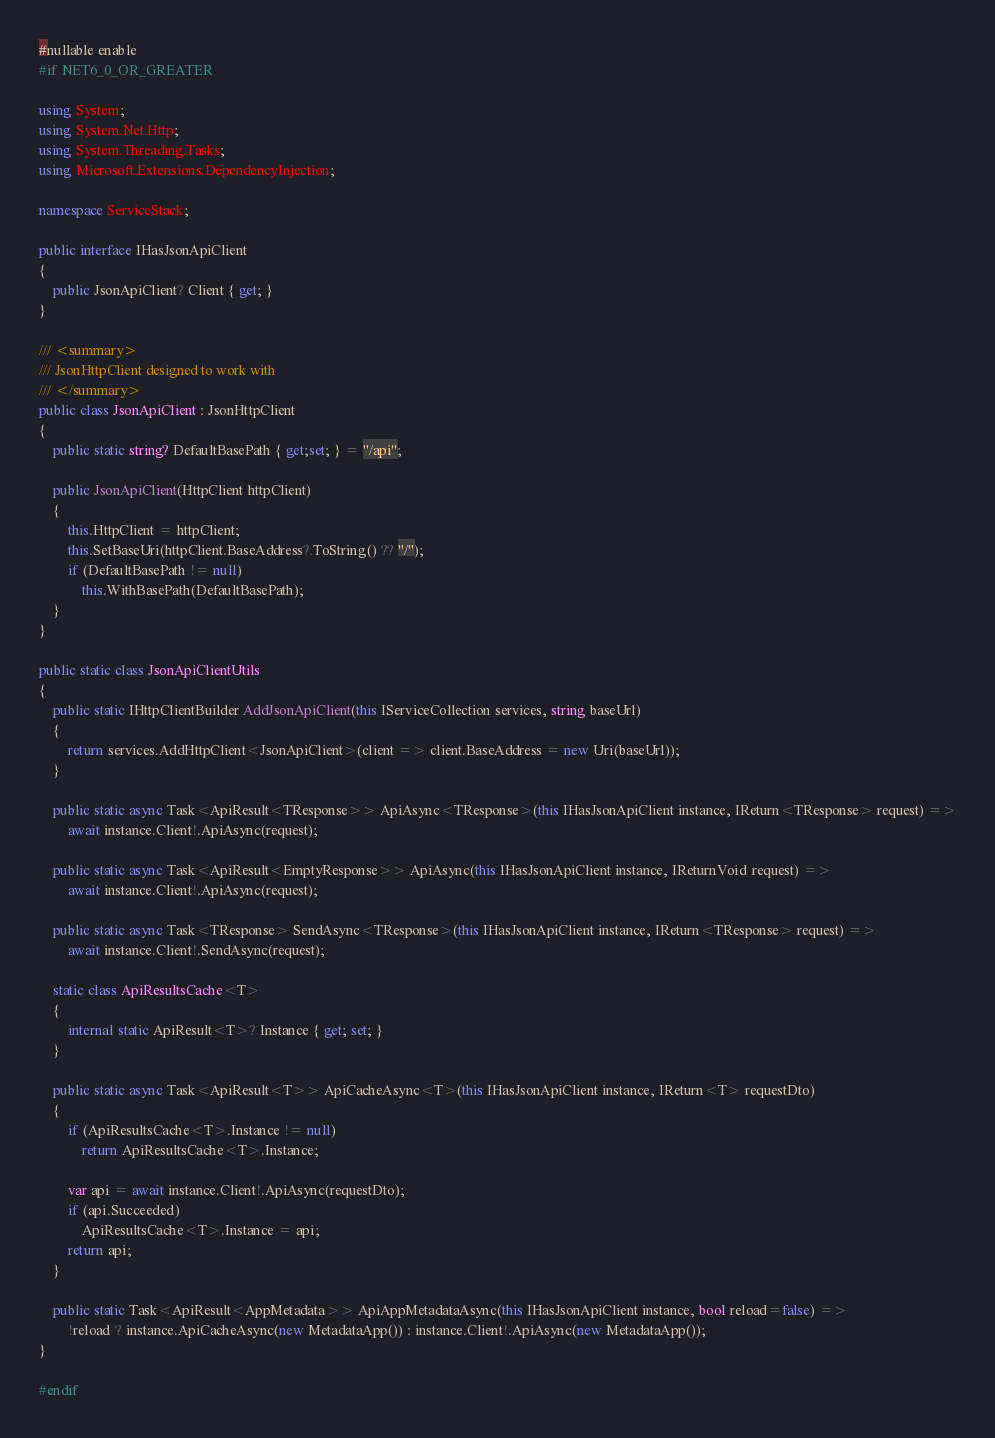<code> <loc_0><loc_0><loc_500><loc_500><_C#_>#nullable enable
#if NET6_0_OR_GREATER

using System;
using System.Net.Http;
using System.Threading.Tasks;
using Microsoft.Extensions.DependencyInjection;

namespace ServiceStack;

public interface IHasJsonApiClient
{
    public JsonApiClient? Client { get; }
}

/// <summary>
/// JsonHttpClient designed to work with 
/// </summary>
public class JsonApiClient : JsonHttpClient
{
    public static string? DefaultBasePath { get;set; } = "/api";

    public JsonApiClient(HttpClient httpClient)
    {
        this.HttpClient = httpClient;
        this.SetBaseUri(httpClient.BaseAddress?.ToString() ?? "/");
        if (DefaultBasePath != null)
            this.WithBasePath(DefaultBasePath);
    }
}

public static class JsonApiClientUtils
{
    public static IHttpClientBuilder AddJsonApiClient(this IServiceCollection services, string baseUrl)
    {
        return services.AddHttpClient<JsonApiClient>(client => client.BaseAddress = new Uri(baseUrl));
    }
    
    public static async Task<ApiResult<TResponse>> ApiAsync<TResponse>(this IHasJsonApiClient instance, IReturn<TResponse> request) =>
        await instance.Client!.ApiAsync(request);

    public static async Task<ApiResult<EmptyResponse>> ApiAsync(this IHasJsonApiClient instance, IReturnVoid request) =>
        await instance.Client!.ApiAsync(request);

    public static async Task<TResponse> SendAsync<TResponse>(this IHasJsonApiClient instance, IReturn<TResponse> request) =>
        await instance.Client!.SendAsync(request);

    static class ApiResultsCache<T>
    {
        internal static ApiResult<T>? Instance { get; set; }
    }

    public static async Task<ApiResult<T>> ApiCacheAsync<T>(this IHasJsonApiClient instance, IReturn<T> requestDto)
    {
        if (ApiResultsCache<T>.Instance != null)
            return ApiResultsCache<T>.Instance;

        var api = await instance.Client!.ApiAsync(requestDto);
        if (api.Succeeded)
            ApiResultsCache<T>.Instance = api;
        return api;
    }

    public static Task<ApiResult<AppMetadata>> ApiAppMetadataAsync(this IHasJsonApiClient instance, bool reload=false) =>
        !reload ? instance.ApiCacheAsync(new MetadataApp()) : instance.Client!.ApiAsync(new MetadataApp());
}

#endif</code> 